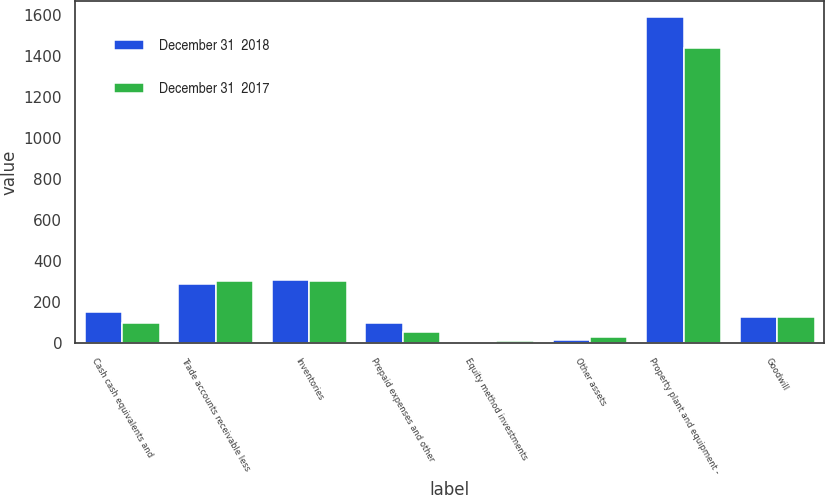Convert chart. <chart><loc_0><loc_0><loc_500><loc_500><stacked_bar_chart><ecel><fcel>Cash cash equivalents and<fcel>Trade accounts receivable less<fcel>Inventories<fcel>Prepaid expenses and other<fcel>Equity method investments<fcel>Other assets<fcel>Property plant and equipment -<fcel>Goodwill<nl><fcel>December 31  2018<fcel>151<fcel>289<fcel>305<fcel>97<fcel>5<fcel>15<fcel>1587<fcel>124<nl><fcel>December 31  2017<fcel>97<fcel>299<fcel>299<fcel>52<fcel>7<fcel>29<fcel>1436<fcel>124<nl></chart> 